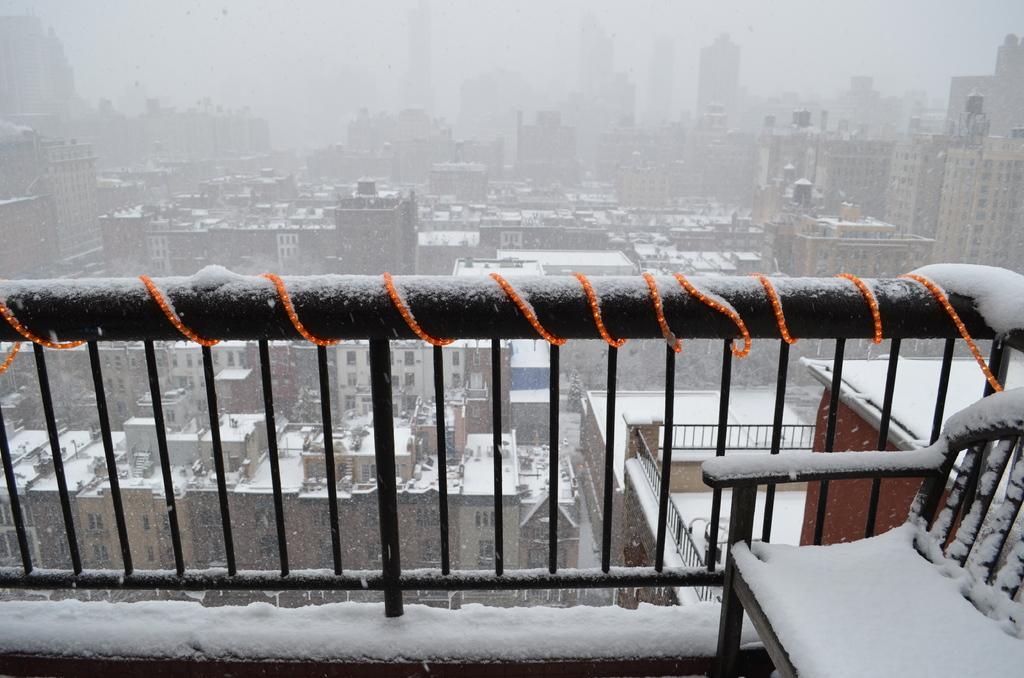Can you describe this image briefly? In this image I can see there is the snow on the iron grill and a chair. At the back side there are buildings with the snow. 